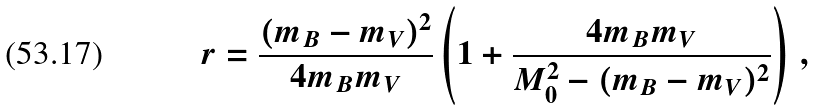Convert formula to latex. <formula><loc_0><loc_0><loc_500><loc_500>r = \frac { ( m _ { B } - m _ { V } ) ^ { 2 } } { 4 m _ { B } m _ { V } } \left ( 1 + \frac { 4 m _ { B } m _ { V } } { M _ { 0 } ^ { 2 } - ( m _ { B } - m _ { V } ) ^ { 2 } } \right ) \, ,</formula> 